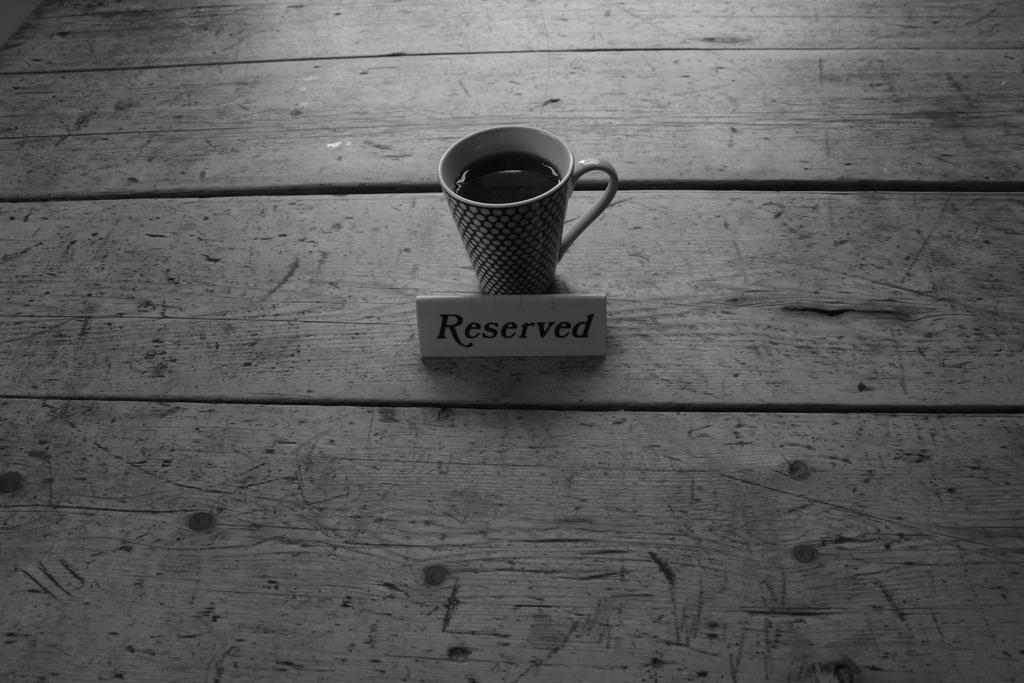What is the main object in the image? There is a coffee cup in the image. Where is the coffee cup placed? The coffee cup is placed on a wooden surface. What other object can be seen in the image? There is a name board in the image. What type of drain is visible in the image? There is no drain present in the image. Is there any lace or button on the coffee cup? No, there is no lace or button on the coffee cup. 